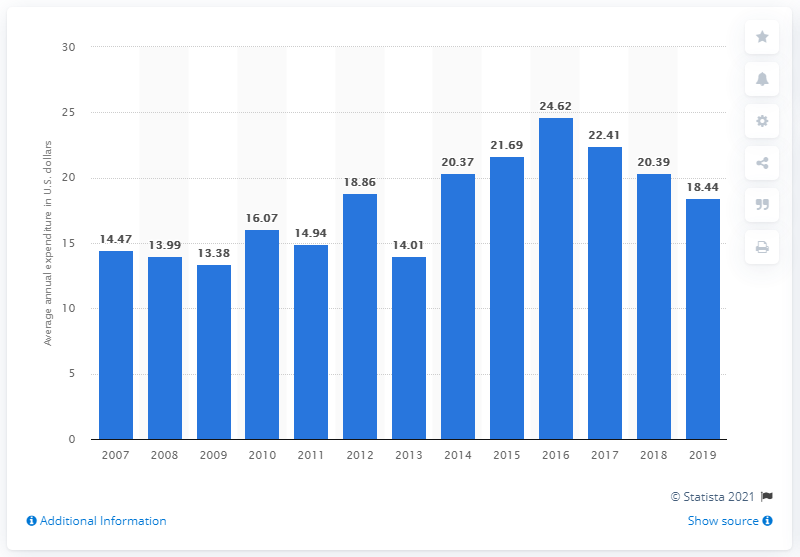Give some essential details in this illustration. In 2019, the average expenditure on non-electric cookware per consumer unit in the United States was $18.44. 